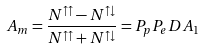<formula> <loc_0><loc_0><loc_500><loc_500>A _ { m } = \frac { N ^ { \uparrow \uparrow } - N ^ { \uparrow \downarrow } } { N ^ { \uparrow \uparrow } + N ^ { \uparrow \downarrow } } = P _ { p } P _ { e } D A _ { 1 }</formula> 